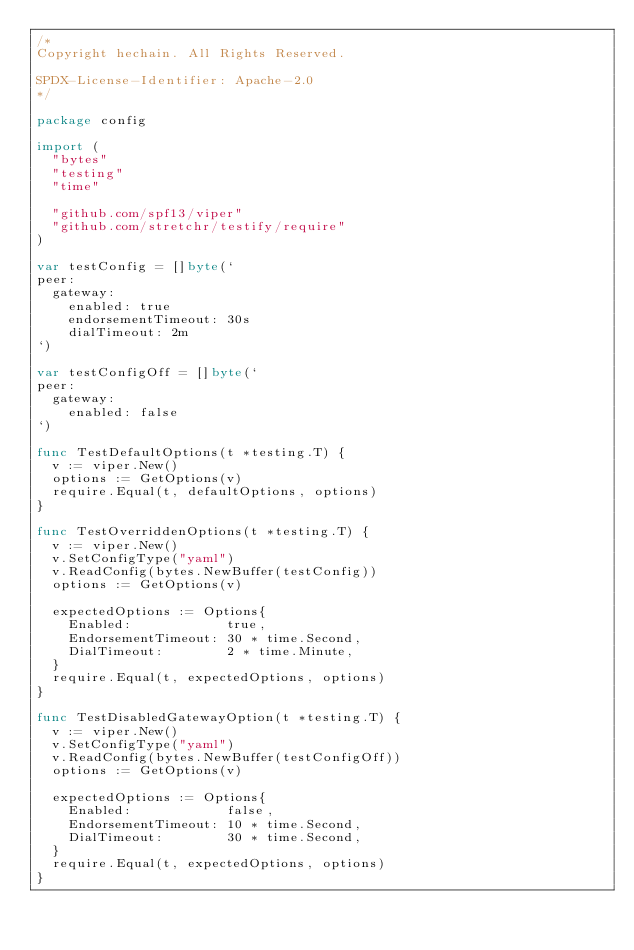Convert code to text. <code><loc_0><loc_0><loc_500><loc_500><_Go_>/*
Copyright hechain. All Rights Reserved.

SPDX-License-Identifier: Apache-2.0
*/

package config

import (
	"bytes"
	"testing"
	"time"

	"github.com/spf13/viper"
	"github.com/stretchr/testify/require"
)

var testConfig = []byte(`
peer:
  gateway:
    enabled: true
    endorsementTimeout: 30s
    dialTimeout: 2m
`)

var testConfigOff = []byte(`
peer:
  gateway:
    enabled: false
`)

func TestDefaultOptions(t *testing.T) {
	v := viper.New()
	options := GetOptions(v)
	require.Equal(t, defaultOptions, options)
}

func TestOverriddenOptions(t *testing.T) {
	v := viper.New()
	v.SetConfigType("yaml")
	v.ReadConfig(bytes.NewBuffer(testConfig))
	options := GetOptions(v)

	expectedOptions := Options{
		Enabled:            true,
		EndorsementTimeout: 30 * time.Second,
		DialTimeout:        2 * time.Minute,
	}
	require.Equal(t, expectedOptions, options)
}

func TestDisabledGatewayOption(t *testing.T) {
	v := viper.New()
	v.SetConfigType("yaml")
	v.ReadConfig(bytes.NewBuffer(testConfigOff))
	options := GetOptions(v)

	expectedOptions := Options{
		Enabled:            false,
		EndorsementTimeout: 10 * time.Second,
		DialTimeout:        30 * time.Second,
	}
	require.Equal(t, expectedOptions, options)
}
</code> 